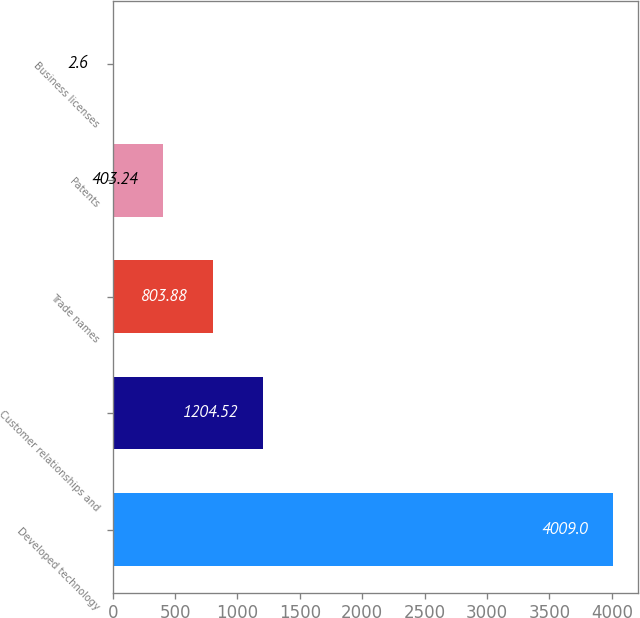Convert chart. <chart><loc_0><loc_0><loc_500><loc_500><bar_chart><fcel>Developed technology<fcel>Customer relationships and<fcel>Trade names<fcel>Patents<fcel>Business licenses<nl><fcel>4009<fcel>1204.52<fcel>803.88<fcel>403.24<fcel>2.6<nl></chart> 